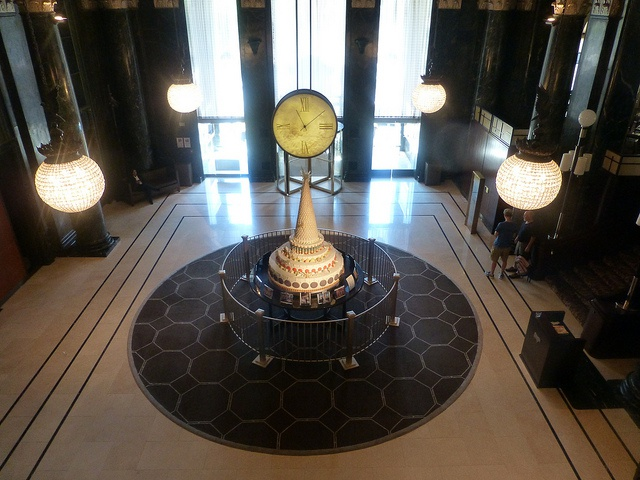Describe the objects in this image and their specific colors. I can see clock in black, tan, khaki, and gray tones, couch in black and gray tones, people in black, gray, and maroon tones, people in black, maroon, and gray tones, and people in black and gray tones in this image. 